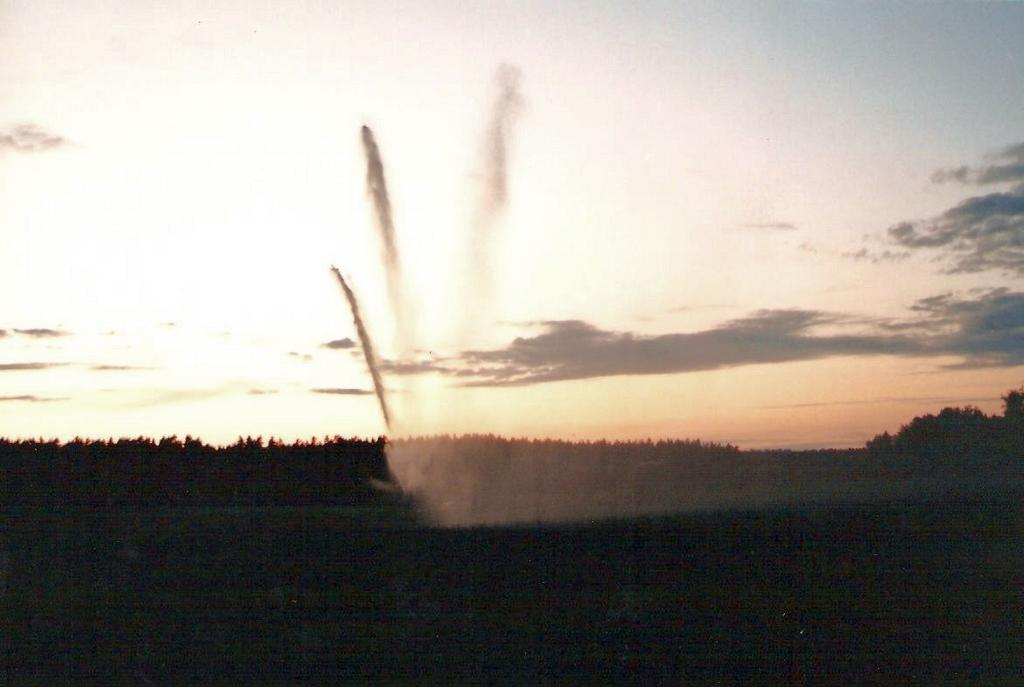What is located at the bottom of the image? There is a walkway at the bottom of the image. What type of vegetation can be seen in the image? There are trees in the image. What is visible in the background of the image? The sky and fog are visible in the background of the image. Where is the drawer located in the image? There is no drawer present in the image. What type of plate is visible in the image? There is no plate present in the image. 